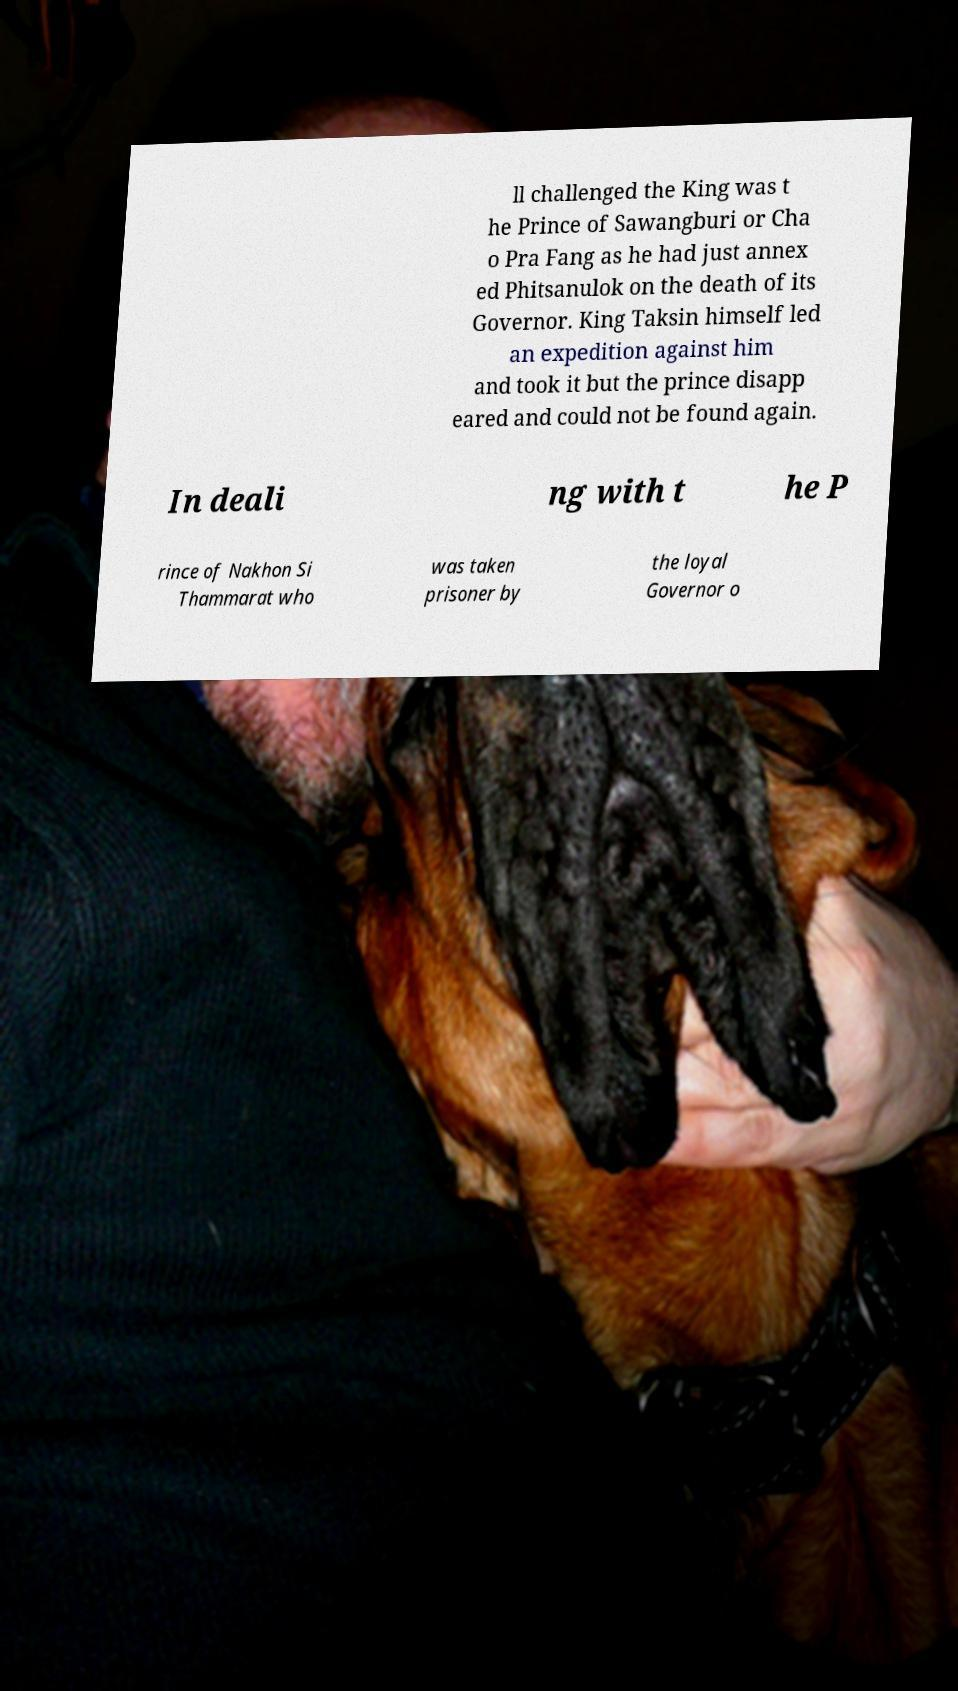Can you accurately transcribe the text from the provided image for me? ll challenged the King was t he Prince of Sawangburi or Cha o Pra Fang as he had just annex ed Phitsanulok on the death of its Governor. King Taksin himself led an expedition against him and took it but the prince disapp eared and could not be found again. In deali ng with t he P rince of Nakhon Si Thammarat who was taken prisoner by the loyal Governor o 